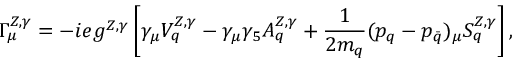<formula> <loc_0><loc_0><loc_500><loc_500>\Gamma _ { \mu } ^ { Z , \gamma } = - i e g ^ { Z , \gamma } \left [ \gamma _ { \mu } V _ { q } ^ { Z , \gamma } - \gamma _ { \mu } \gamma _ { 5 } A _ { q } ^ { Z , \gamma } + \frac { 1 } { 2 m _ { q } } ( p _ { q } - p _ { \bar { q } } ) _ { \mu } S _ { q } ^ { Z , \gamma } \right ] ,</formula> 